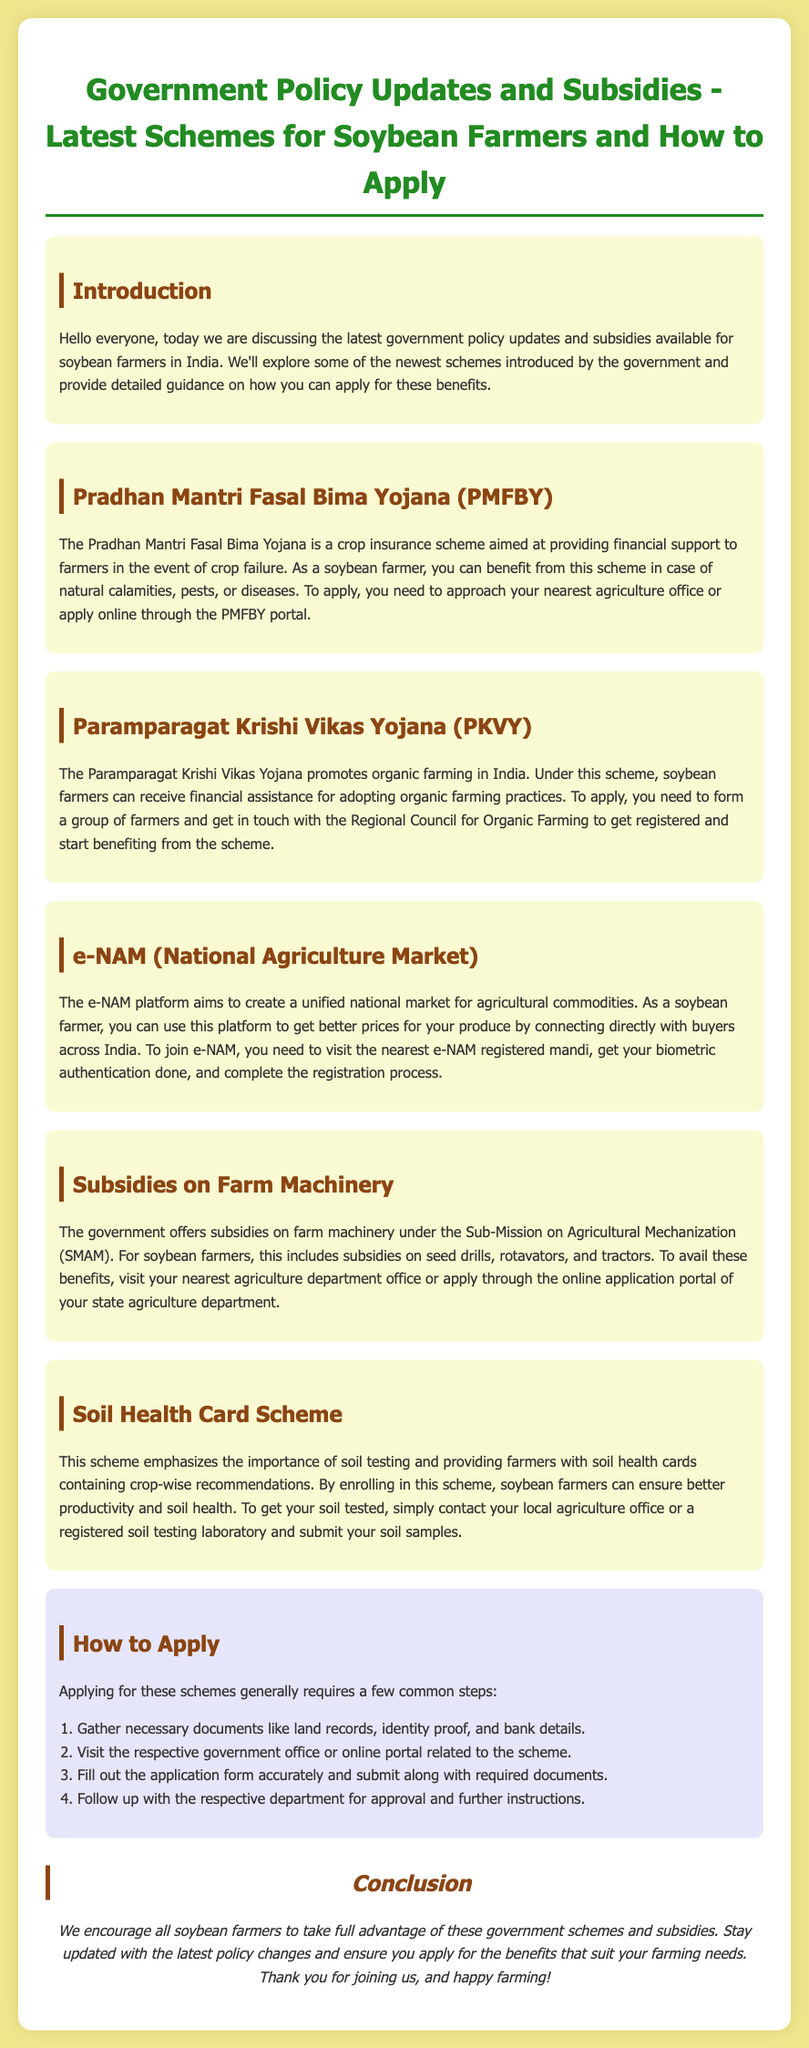What is the main purpose of the Pradhan Mantri Fasal Bima Yojana? The main purpose of the Pradhan Mantri Fasal Bima Yojana is to provide financial support to farmers in the event of crop failure.
Answer: financial support Who do soybean farmers need to contact to apply for the Paramparagat Krishi Vikas Yojana? Soybean farmers need to contact the Regional Council for Organic Farming to apply for the Paramparagat Krishi Vikas Yojana.
Answer: Regional Council for Organic Farming What type of market does e-NAM aim to create? e-NAM aims to create a unified national market for agricultural commodities.
Answer: unified national market What type of subsidies are available under the Sub-Mission on Agricultural Mechanization? The government offers subsidies on farm machinery under the Sub-Mission on Agricultural Mechanization.
Answer: farm machinery What is required to get your soil tested under the Soil Health Card Scheme? To get your soil tested, you need to contact your local agriculture office or a registered soil testing laboratory.
Answer: local agriculture office or registered soil testing laboratory How many steps are mentioned for applying to these schemes? The document mentions four steps for applying to these schemes.
Answer: four steps What is the color scheme of the background in the document? The background color of the document is light yellow.
Answer: light yellow What should soybean farmers do after submitting their application? After submitting their application, soybean farmers should follow up with the respective department for approval.
Answer: follow up with the respective department 